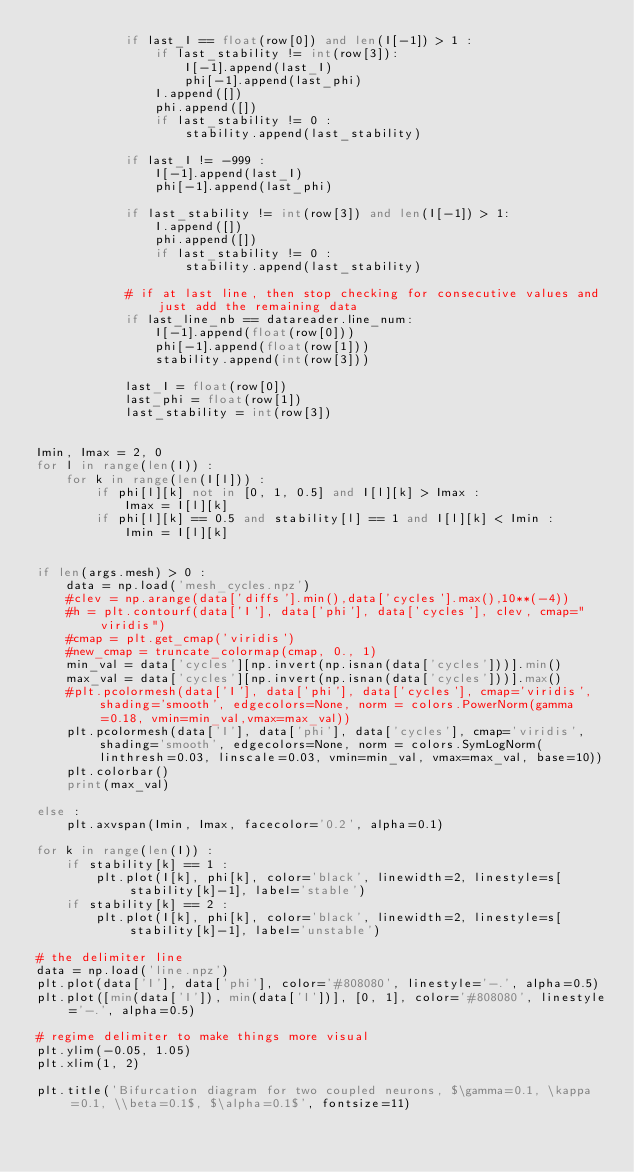Convert code to text. <code><loc_0><loc_0><loc_500><loc_500><_Python_>            if last_I == float(row[0]) and len(I[-1]) > 1 :
                if last_stability != int(row[3]):
                    I[-1].append(last_I)
                    phi[-1].append(last_phi)
                I.append([])
                phi.append([])
                if last_stability != 0 :
                    stability.append(last_stability)

            if last_I != -999 :
                I[-1].append(last_I)
                phi[-1].append(last_phi)

            if last_stability != int(row[3]) and len(I[-1]) > 1:
                I.append([])
                phi.append([])
                if last_stability != 0 :
                    stability.append(last_stability)

            # if at last line, then stop checking for consecutive values and just add the remaining data
            if last_line_nb == datareader.line_num:
                I[-1].append(float(row[0]))
                phi[-1].append(float(row[1]))
                stability.append(int(row[3]))

            last_I = float(row[0])
            last_phi = float(row[1])
            last_stability = int(row[3])


Imin, Imax = 2, 0
for l in range(len(I)) :
    for k in range(len(I[l])) :
        if phi[l][k] not in [0, 1, 0.5] and I[l][k] > Imax :
            Imax = I[l][k]
        if phi[l][k] == 0.5 and stability[l] == 1 and I[l][k] < Imin :
            Imin = I[l][k]


if len(args.mesh) > 0 :
    data = np.load('mesh_cycles.npz')
    #clev = np.arange(data['diffs'].min(),data['cycles'].max(),10**(-4))
    #h = plt.contourf(data['I'], data['phi'], data['cycles'], clev, cmap="viridis")
    #cmap = plt.get_cmap('viridis')
    #new_cmap = truncate_colormap(cmap, 0., 1)
    min_val = data['cycles'][np.invert(np.isnan(data['cycles']))].min()
    max_val = data['cycles'][np.invert(np.isnan(data['cycles']))].max()
    #plt.pcolormesh(data['I'], data['phi'], data['cycles'], cmap='viridis', shading='smooth', edgecolors=None, norm = colors.PowerNorm(gamma=0.18, vmin=min_val,vmax=max_val))
    plt.pcolormesh(data['I'], data['phi'], data['cycles'], cmap='viridis', shading='smooth', edgecolors=None, norm = colors.SymLogNorm(linthresh=0.03, linscale=0.03, vmin=min_val, vmax=max_val, base=10))
    plt.colorbar()
    print(max_val)

else :
    plt.axvspan(Imin, Imax, facecolor='0.2', alpha=0.1)

for k in range(len(I)) :
    if stability[k] == 1 :
        plt.plot(I[k], phi[k], color='black', linewidth=2, linestyle=s[stability[k]-1], label='stable')
    if stability[k] == 2 :
        plt.plot(I[k], phi[k], color='black', linewidth=2, linestyle=s[stability[k]-1], label='unstable')

# the delimiter line
data = np.load('line.npz')
plt.plot(data['I'], data['phi'], color='#808080', linestyle='-.', alpha=0.5)
plt.plot([min(data['I']), min(data['I'])], [0, 1], color='#808080', linestyle='-.', alpha=0.5)

# regime delimiter to make things more visual
plt.ylim(-0.05, 1.05)
plt.xlim(1, 2)

plt.title('Bifurcation diagram for two coupled neurons, $\gamma=0.1, \kappa=0.1, \\beta=0.1$, $\alpha=0.1$', fontsize=11)</code> 